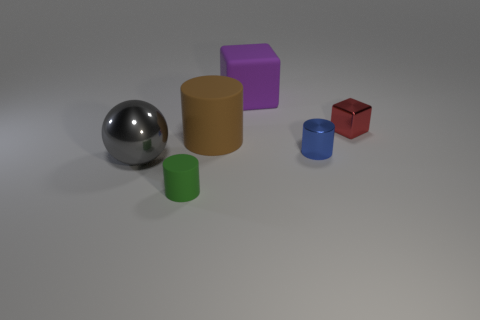Subtract all blue cylinders. How many cylinders are left? 2 Add 1 small brown spheres. How many objects exist? 7 Subtract all spheres. How many objects are left? 5 Subtract all purple cubes. How many cubes are left? 1 Subtract all tiny green cylinders. Subtract all small rubber objects. How many objects are left? 4 Add 6 gray spheres. How many gray spheres are left? 7 Add 4 large gray spheres. How many large gray spheres exist? 5 Subtract 0 yellow blocks. How many objects are left? 6 Subtract all blue cubes. Subtract all gray balls. How many cubes are left? 2 